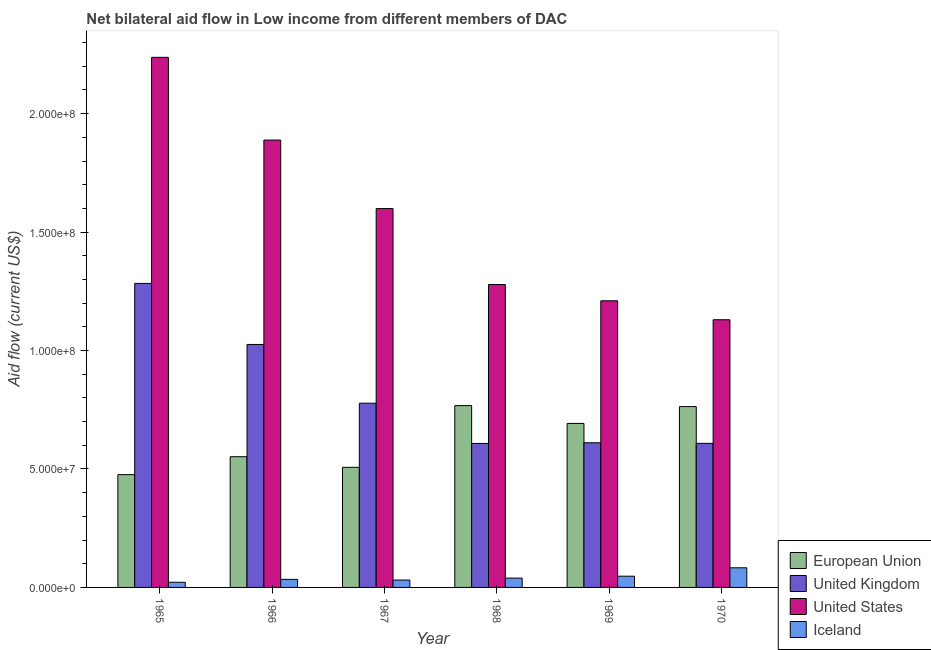How many different coloured bars are there?
Provide a succinct answer. 4. Are the number of bars on each tick of the X-axis equal?
Keep it short and to the point. Yes. How many bars are there on the 4th tick from the left?
Provide a short and direct response. 4. How many bars are there on the 6th tick from the right?
Ensure brevity in your answer.  4. What is the label of the 3rd group of bars from the left?
Your answer should be very brief. 1967. What is the amount of aid given by us in 1968?
Offer a very short reply. 1.28e+08. Across all years, what is the maximum amount of aid given by eu?
Provide a succinct answer. 7.68e+07. Across all years, what is the minimum amount of aid given by us?
Your response must be concise. 1.13e+08. In which year was the amount of aid given by uk maximum?
Your answer should be compact. 1965. In which year was the amount of aid given by us minimum?
Keep it short and to the point. 1970. What is the total amount of aid given by eu in the graph?
Provide a succinct answer. 3.76e+08. What is the difference between the amount of aid given by eu in 1968 and that in 1970?
Provide a short and direct response. 4.10e+05. What is the difference between the amount of aid given by iceland in 1967 and the amount of aid given by uk in 1966?
Ensure brevity in your answer.  -2.80e+05. What is the average amount of aid given by uk per year?
Your response must be concise. 8.19e+07. What is the ratio of the amount of aid given by eu in 1966 to that in 1968?
Your answer should be compact. 0.72. What is the difference between the highest and the second highest amount of aid given by us?
Ensure brevity in your answer.  3.49e+07. What is the difference between the highest and the lowest amount of aid given by uk?
Ensure brevity in your answer.  6.76e+07. In how many years, is the amount of aid given by uk greater than the average amount of aid given by uk taken over all years?
Provide a short and direct response. 2. What does the 1st bar from the left in 1965 represents?
Ensure brevity in your answer.  European Union. How many bars are there?
Ensure brevity in your answer.  24. Are all the bars in the graph horizontal?
Keep it short and to the point. No. How many years are there in the graph?
Offer a very short reply. 6. What is the difference between two consecutive major ticks on the Y-axis?
Provide a short and direct response. 5.00e+07. What is the title of the graph?
Provide a succinct answer. Net bilateral aid flow in Low income from different members of DAC. What is the Aid flow (current US$) of European Union in 1965?
Your answer should be compact. 4.76e+07. What is the Aid flow (current US$) in United Kingdom in 1965?
Give a very brief answer. 1.28e+08. What is the Aid flow (current US$) of United States in 1965?
Ensure brevity in your answer.  2.24e+08. What is the Aid flow (current US$) of Iceland in 1965?
Offer a very short reply. 2.18e+06. What is the Aid flow (current US$) of European Union in 1966?
Give a very brief answer. 5.52e+07. What is the Aid flow (current US$) of United Kingdom in 1966?
Make the answer very short. 1.03e+08. What is the Aid flow (current US$) in United States in 1966?
Your answer should be compact. 1.89e+08. What is the Aid flow (current US$) in Iceland in 1966?
Your answer should be compact. 3.40e+06. What is the Aid flow (current US$) of European Union in 1967?
Your answer should be compact. 5.07e+07. What is the Aid flow (current US$) of United Kingdom in 1967?
Your answer should be compact. 7.78e+07. What is the Aid flow (current US$) in United States in 1967?
Give a very brief answer. 1.60e+08. What is the Aid flow (current US$) in Iceland in 1967?
Your response must be concise. 3.12e+06. What is the Aid flow (current US$) in European Union in 1968?
Keep it short and to the point. 7.68e+07. What is the Aid flow (current US$) in United Kingdom in 1968?
Offer a very short reply. 6.08e+07. What is the Aid flow (current US$) of United States in 1968?
Give a very brief answer. 1.28e+08. What is the Aid flow (current US$) of Iceland in 1968?
Ensure brevity in your answer.  3.94e+06. What is the Aid flow (current US$) of European Union in 1969?
Your answer should be very brief. 6.92e+07. What is the Aid flow (current US$) of United Kingdom in 1969?
Make the answer very short. 6.11e+07. What is the Aid flow (current US$) in United States in 1969?
Give a very brief answer. 1.21e+08. What is the Aid flow (current US$) in Iceland in 1969?
Provide a succinct answer. 4.74e+06. What is the Aid flow (current US$) of European Union in 1970?
Offer a terse response. 7.63e+07. What is the Aid flow (current US$) of United Kingdom in 1970?
Make the answer very short. 6.08e+07. What is the Aid flow (current US$) in United States in 1970?
Ensure brevity in your answer.  1.13e+08. What is the Aid flow (current US$) in Iceland in 1970?
Provide a succinct answer. 8.29e+06. Across all years, what is the maximum Aid flow (current US$) of European Union?
Your answer should be compact. 7.68e+07. Across all years, what is the maximum Aid flow (current US$) in United Kingdom?
Your response must be concise. 1.28e+08. Across all years, what is the maximum Aid flow (current US$) of United States?
Your answer should be very brief. 2.24e+08. Across all years, what is the maximum Aid flow (current US$) in Iceland?
Make the answer very short. 8.29e+06. Across all years, what is the minimum Aid flow (current US$) of European Union?
Your response must be concise. 4.76e+07. Across all years, what is the minimum Aid flow (current US$) in United Kingdom?
Provide a short and direct response. 6.08e+07. Across all years, what is the minimum Aid flow (current US$) of United States?
Ensure brevity in your answer.  1.13e+08. Across all years, what is the minimum Aid flow (current US$) of Iceland?
Keep it short and to the point. 2.18e+06. What is the total Aid flow (current US$) of European Union in the graph?
Make the answer very short. 3.76e+08. What is the total Aid flow (current US$) in United Kingdom in the graph?
Your response must be concise. 4.91e+08. What is the total Aid flow (current US$) of United States in the graph?
Offer a very short reply. 9.34e+08. What is the total Aid flow (current US$) of Iceland in the graph?
Your answer should be very brief. 2.57e+07. What is the difference between the Aid flow (current US$) in European Union in 1965 and that in 1966?
Your response must be concise. -7.57e+06. What is the difference between the Aid flow (current US$) in United Kingdom in 1965 and that in 1966?
Ensure brevity in your answer.  2.58e+07. What is the difference between the Aid flow (current US$) in United States in 1965 and that in 1966?
Provide a short and direct response. 3.49e+07. What is the difference between the Aid flow (current US$) of Iceland in 1965 and that in 1966?
Keep it short and to the point. -1.22e+06. What is the difference between the Aid flow (current US$) of European Union in 1965 and that in 1967?
Offer a terse response. -3.09e+06. What is the difference between the Aid flow (current US$) of United Kingdom in 1965 and that in 1967?
Ensure brevity in your answer.  5.06e+07. What is the difference between the Aid flow (current US$) of United States in 1965 and that in 1967?
Your response must be concise. 6.38e+07. What is the difference between the Aid flow (current US$) in Iceland in 1965 and that in 1967?
Ensure brevity in your answer.  -9.40e+05. What is the difference between the Aid flow (current US$) in European Union in 1965 and that in 1968?
Provide a succinct answer. -2.91e+07. What is the difference between the Aid flow (current US$) of United Kingdom in 1965 and that in 1968?
Give a very brief answer. 6.76e+07. What is the difference between the Aid flow (current US$) of United States in 1965 and that in 1968?
Offer a very short reply. 9.59e+07. What is the difference between the Aid flow (current US$) of Iceland in 1965 and that in 1968?
Your answer should be very brief. -1.76e+06. What is the difference between the Aid flow (current US$) of European Union in 1965 and that in 1969?
Offer a terse response. -2.16e+07. What is the difference between the Aid flow (current US$) in United Kingdom in 1965 and that in 1969?
Your response must be concise. 6.73e+07. What is the difference between the Aid flow (current US$) of United States in 1965 and that in 1969?
Offer a very short reply. 1.03e+08. What is the difference between the Aid flow (current US$) of Iceland in 1965 and that in 1969?
Provide a short and direct response. -2.56e+06. What is the difference between the Aid flow (current US$) in European Union in 1965 and that in 1970?
Provide a succinct answer. -2.87e+07. What is the difference between the Aid flow (current US$) in United Kingdom in 1965 and that in 1970?
Your response must be concise. 6.75e+07. What is the difference between the Aid flow (current US$) in United States in 1965 and that in 1970?
Ensure brevity in your answer.  1.11e+08. What is the difference between the Aid flow (current US$) in Iceland in 1965 and that in 1970?
Offer a terse response. -6.11e+06. What is the difference between the Aid flow (current US$) in European Union in 1966 and that in 1967?
Offer a very short reply. 4.48e+06. What is the difference between the Aid flow (current US$) in United Kingdom in 1966 and that in 1967?
Your response must be concise. 2.48e+07. What is the difference between the Aid flow (current US$) of United States in 1966 and that in 1967?
Ensure brevity in your answer.  2.89e+07. What is the difference between the Aid flow (current US$) of European Union in 1966 and that in 1968?
Keep it short and to the point. -2.16e+07. What is the difference between the Aid flow (current US$) in United Kingdom in 1966 and that in 1968?
Ensure brevity in your answer.  4.18e+07. What is the difference between the Aid flow (current US$) of United States in 1966 and that in 1968?
Provide a short and direct response. 6.10e+07. What is the difference between the Aid flow (current US$) of Iceland in 1966 and that in 1968?
Ensure brevity in your answer.  -5.40e+05. What is the difference between the Aid flow (current US$) of European Union in 1966 and that in 1969?
Your answer should be very brief. -1.40e+07. What is the difference between the Aid flow (current US$) of United Kingdom in 1966 and that in 1969?
Your answer should be very brief. 4.15e+07. What is the difference between the Aid flow (current US$) of United States in 1966 and that in 1969?
Provide a succinct answer. 6.78e+07. What is the difference between the Aid flow (current US$) in Iceland in 1966 and that in 1969?
Your response must be concise. -1.34e+06. What is the difference between the Aid flow (current US$) in European Union in 1966 and that in 1970?
Your answer should be compact. -2.12e+07. What is the difference between the Aid flow (current US$) of United Kingdom in 1966 and that in 1970?
Make the answer very short. 4.18e+07. What is the difference between the Aid flow (current US$) of United States in 1966 and that in 1970?
Your answer should be very brief. 7.58e+07. What is the difference between the Aid flow (current US$) in Iceland in 1966 and that in 1970?
Offer a very short reply. -4.89e+06. What is the difference between the Aid flow (current US$) in European Union in 1967 and that in 1968?
Ensure brevity in your answer.  -2.60e+07. What is the difference between the Aid flow (current US$) of United Kingdom in 1967 and that in 1968?
Provide a succinct answer. 1.70e+07. What is the difference between the Aid flow (current US$) of United States in 1967 and that in 1968?
Provide a succinct answer. 3.21e+07. What is the difference between the Aid flow (current US$) in Iceland in 1967 and that in 1968?
Make the answer very short. -8.20e+05. What is the difference between the Aid flow (current US$) of European Union in 1967 and that in 1969?
Your answer should be very brief. -1.85e+07. What is the difference between the Aid flow (current US$) of United Kingdom in 1967 and that in 1969?
Your response must be concise. 1.67e+07. What is the difference between the Aid flow (current US$) in United States in 1967 and that in 1969?
Make the answer very short. 3.89e+07. What is the difference between the Aid flow (current US$) in Iceland in 1967 and that in 1969?
Offer a terse response. -1.62e+06. What is the difference between the Aid flow (current US$) of European Union in 1967 and that in 1970?
Your response must be concise. -2.56e+07. What is the difference between the Aid flow (current US$) in United Kingdom in 1967 and that in 1970?
Your response must be concise. 1.70e+07. What is the difference between the Aid flow (current US$) of United States in 1967 and that in 1970?
Your response must be concise. 4.69e+07. What is the difference between the Aid flow (current US$) in Iceland in 1967 and that in 1970?
Keep it short and to the point. -5.17e+06. What is the difference between the Aid flow (current US$) in European Union in 1968 and that in 1969?
Keep it short and to the point. 7.52e+06. What is the difference between the Aid flow (current US$) of United States in 1968 and that in 1969?
Give a very brief answer. 6.85e+06. What is the difference between the Aid flow (current US$) of Iceland in 1968 and that in 1969?
Your response must be concise. -8.00e+05. What is the difference between the Aid flow (current US$) of United States in 1968 and that in 1970?
Your answer should be compact. 1.48e+07. What is the difference between the Aid flow (current US$) of Iceland in 1968 and that in 1970?
Your response must be concise. -4.35e+06. What is the difference between the Aid flow (current US$) of European Union in 1969 and that in 1970?
Offer a terse response. -7.11e+06. What is the difference between the Aid flow (current US$) in United Kingdom in 1969 and that in 1970?
Your response must be concise. 2.60e+05. What is the difference between the Aid flow (current US$) of United States in 1969 and that in 1970?
Make the answer very short. 8.00e+06. What is the difference between the Aid flow (current US$) of Iceland in 1969 and that in 1970?
Your response must be concise. -3.55e+06. What is the difference between the Aid flow (current US$) of European Union in 1965 and the Aid flow (current US$) of United Kingdom in 1966?
Offer a terse response. -5.50e+07. What is the difference between the Aid flow (current US$) in European Union in 1965 and the Aid flow (current US$) in United States in 1966?
Offer a very short reply. -1.41e+08. What is the difference between the Aid flow (current US$) in European Union in 1965 and the Aid flow (current US$) in Iceland in 1966?
Make the answer very short. 4.42e+07. What is the difference between the Aid flow (current US$) in United Kingdom in 1965 and the Aid flow (current US$) in United States in 1966?
Offer a very short reply. -6.05e+07. What is the difference between the Aid flow (current US$) in United Kingdom in 1965 and the Aid flow (current US$) in Iceland in 1966?
Keep it short and to the point. 1.25e+08. What is the difference between the Aid flow (current US$) of United States in 1965 and the Aid flow (current US$) of Iceland in 1966?
Provide a short and direct response. 2.20e+08. What is the difference between the Aid flow (current US$) of European Union in 1965 and the Aid flow (current US$) of United Kingdom in 1967?
Offer a terse response. -3.02e+07. What is the difference between the Aid flow (current US$) in European Union in 1965 and the Aid flow (current US$) in United States in 1967?
Provide a short and direct response. -1.12e+08. What is the difference between the Aid flow (current US$) in European Union in 1965 and the Aid flow (current US$) in Iceland in 1967?
Give a very brief answer. 4.45e+07. What is the difference between the Aid flow (current US$) in United Kingdom in 1965 and the Aid flow (current US$) in United States in 1967?
Keep it short and to the point. -3.16e+07. What is the difference between the Aid flow (current US$) in United Kingdom in 1965 and the Aid flow (current US$) in Iceland in 1967?
Offer a very short reply. 1.25e+08. What is the difference between the Aid flow (current US$) in United States in 1965 and the Aid flow (current US$) in Iceland in 1967?
Keep it short and to the point. 2.21e+08. What is the difference between the Aid flow (current US$) of European Union in 1965 and the Aid flow (current US$) of United Kingdom in 1968?
Your response must be concise. -1.32e+07. What is the difference between the Aid flow (current US$) in European Union in 1965 and the Aid flow (current US$) in United States in 1968?
Provide a short and direct response. -8.02e+07. What is the difference between the Aid flow (current US$) of European Union in 1965 and the Aid flow (current US$) of Iceland in 1968?
Offer a terse response. 4.37e+07. What is the difference between the Aid flow (current US$) of United Kingdom in 1965 and the Aid flow (current US$) of United States in 1968?
Provide a succinct answer. 4.80e+05. What is the difference between the Aid flow (current US$) of United Kingdom in 1965 and the Aid flow (current US$) of Iceland in 1968?
Offer a terse response. 1.24e+08. What is the difference between the Aid flow (current US$) in United States in 1965 and the Aid flow (current US$) in Iceland in 1968?
Offer a very short reply. 2.20e+08. What is the difference between the Aid flow (current US$) of European Union in 1965 and the Aid flow (current US$) of United Kingdom in 1969?
Your response must be concise. -1.35e+07. What is the difference between the Aid flow (current US$) in European Union in 1965 and the Aid flow (current US$) in United States in 1969?
Offer a very short reply. -7.34e+07. What is the difference between the Aid flow (current US$) of European Union in 1965 and the Aid flow (current US$) of Iceland in 1969?
Keep it short and to the point. 4.29e+07. What is the difference between the Aid flow (current US$) of United Kingdom in 1965 and the Aid flow (current US$) of United States in 1969?
Your answer should be very brief. 7.33e+06. What is the difference between the Aid flow (current US$) of United Kingdom in 1965 and the Aid flow (current US$) of Iceland in 1969?
Give a very brief answer. 1.24e+08. What is the difference between the Aid flow (current US$) in United States in 1965 and the Aid flow (current US$) in Iceland in 1969?
Provide a succinct answer. 2.19e+08. What is the difference between the Aid flow (current US$) in European Union in 1965 and the Aid flow (current US$) in United Kingdom in 1970?
Keep it short and to the point. -1.32e+07. What is the difference between the Aid flow (current US$) in European Union in 1965 and the Aid flow (current US$) in United States in 1970?
Give a very brief answer. -6.54e+07. What is the difference between the Aid flow (current US$) of European Union in 1965 and the Aid flow (current US$) of Iceland in 1970?
Ensure brevity in your answer.  3.93e+07. What is the difference between the Aid flow (current US$) of United Kingdom in 1965 and the Aid flow (current US$) of United States in 1970?
Provide a succinct answer. 1.53e+07. What is the difference between the Aid flow (current US$) in United Kingdom in 1965 and the Aid flow (current US$) in Iceland in 1970?
Your answer should be compact. 1.20e+08. What is the difference between the Aid flow (current US$) in United States in 1965 and the Aid flow (current US$) in Iceland in 1970?
Your answer should be very brief. 2.15e+08. What is the difference between the Aid flow (current US$) in European Union in 1966 and the Aid flow (current US$) in United Kingdom in 1967?
Provide a short and direct response. -2.26e+07. What is the difference between the Aid flow (current US$) in European Union in 1966 and the Aid flow (current US$) in United States in 1967?
Your response must be concise. -1.05e+08. What is the difference between the Aid flow (current US$) in European Union in 1966 and the Aid flow (current US$) in Iceland in 1967?
Keep it short and to the point. 5.21e+07. What is the difference between the Aid flow (current US$) in United Kingdom in 1966 and the Aid flow (current US$) in United States in 1967?
Provide a succinct answer. -5.74e+07. What is the difference between the Aid flow (current US$) of United Kingdom in 1966 and the Aid flow (current US$) of Iceland in 1967?
Your answer should be compact. 9.94e+07. What is the difference between the Aid flow (current US$) in United States in 1966 and the Aid flow (current US$) in Iceland in 1967?
Provide a succinct answer. 1.86e+08. What is the difference between the Aid flow (current US$) in European Union in 1966 and the Aid flow (current US$) in United Kingdom in 1968?
Your answer should be very brief. -5.60e+06. What is the difference between the Aid flow (current US$) of European Union in 1966 and the Aid flow (current US$) of United States in 1968?
Your answer should be compact. -7.27e+07. What is the difference between the Aid flow (current US$) in European Union in 1966 and the Aid flow (current US$) in Iceland in 1968?
Your answer should be very brief. 5.12e+07. What is the difference between the Aid flow (current US$) of United Kingdom in 1966 and the Aid flow (current US$) of United States in 1968?
Your answer should be very brief. -2.53e+07. What is the difference between the Aid flow (current US$) of United Kingdom in 1966 and the Aid flow (current US$) of Iceland in 1968?
Give a very brief answer. 9.86e+07. What is the difference between the Aid flow (current US$) in United States in 1966 and the Aid flow (current US$) in Iceland in 1968?
Keep it short and to the point. 1.85e+08. What is the difference between the Aid flow (current US$) of European Union in 1966 and the Aid flow (current US$) of United Kingdom in 1969?
Provide a short and direct response. -5.89e+06. What is the difference between the Aid flow (current US$) in European Union in 1966 and the Aid flow (current US$) in United States in 1969?
Keep it short and to the point. -6.58e+07. What is the difference between the Aid flow (current US$) in European Union in 1966 and the Aid flow (current US$) in Iceland in 1969?
Ensure brevity in your answer.  5.04e+07. What is the difference between the Aid flow (current US$) of United Kingdom in 1966 and the Aid flow (current US$) of United States in 1969?
Keep it short and to the point. -1.84e+07. What is the difference between the Aid flow (current US$) in United Kingdom in 1966 and the Aid flow (current US$) in Iceland in 1969?
Offer a terse response. 9.78e+07. What is the difference between the Aid flow (current US$) of United States in 1966 and the Aid flow (current US$) of Iceland in 1969?
Keep it short and to the point. 1.84e+08. What is the difference between the Aid flow (current US$) of European Union in 1966 and the Aid flow (current US$) of United Kingdom in 1970?
Your response must be concise. -5.63e+06. What is the difference between the Aid flow (current US$) of European Union in 1966 and the Aid flow (current US$) of United States in 1970?
Your answer should be very brief. -5.78e+07. What is the difference between the Aid flow (current US$) in European Union in 1966 and the Aid flow (current US$) in Iceland in 1970?
Offer a very short reply. 4.69e+07. What is the difference between the Aid flow (current US$) of United Kingdom in 1966 and the Aid flow (current US$) of United States in 1970?
Offer a terse response. -1.04e+07. What is the difference between the Aid flow (current US$) in United Kingdom in 1966 and the Aid flow (current US$) in Iceland in 1970?
Offer a terse response. 9.43e+07. What is the difference between the Aid flow (current US$) of United States in 1966 and the Aid flow (current US$) of Iceland in 1970?
Offer a terse response. 1.81e+08. What is the difference between the Aid flow (current US$) in European Union in 1967 and the Aid flow (current US$) in United Kingdom in 1968?
Your answer should be compact. -1.01e+07. What is the difference between the Aid flow (current US$) in European Union in 1967 and the Aid flow (current US$) in United States in 1968?
Provide a short and direct response. -7.72e+07. What is the difference between the Aid flow (current US$) in European Union in 1967 and the Aid flow (current US$) in Iceland in 1968?
Offer a very short reply. 4.68e+07. What is the difference between the Aid flow (current US$) of United Kingdom in 1967 and the Aid flow (current US$) of United States in 1968?
Provide a short and direct response. -5.01e+07. What is the difference between the Aid flow (current US$) in United Kingdom in 1967 and the Aid flow (current US$) in Iceland in 1968?
Offer a very short reply. 7.38e+07. What is the difference between the Aid flow (current US$) in United States in 1967 and the Aid flow (current US$) in Iceland in 1968?
Provide a succinct answer. 1.56e+08. What is the difference between the Aid flow (current US$) of European Union in 1967 and the Aid flow (current US$) of United Kingdom in 1969?
Give a very brief answer. -1.04e+07. What is the difference between the Aid flow (current US$) of European Union in 1967 and the Aid flow (current US$) of United States in 1969?
Give a very brief answer. -7.03e+07. What is the difference between the Aid flow (current US$) of European Union in 1967 and the Aid flow (current US$) of Iceland in 1969?
Your response must be concise. 4.60e+07. What is the difference between the Aid flow (current US$) of United Kingdom in 1967 and the Aid flow (current US$) of United States in 1969?
Provide a succinct answer. -4.32e+07. What is the difference between the Aid flow (current US$) of United Kingdom in 1967 and the Aid flow (current US$) of Iceland in 1969?
Keep it short and to the point. 7.30e+07. What is the difference between the Aid flow (current US$) in United States in 1967 and the Aid flow (current US$) in Iceland in 1969?
Offer a very short reply. 1.55e+08. What is the difference between the Aid flow (current US$) in European Union in 1967 and the Aid flow (current US$) in United Kingdom in 1970?
Offer a terse response. -1.01e+07. What is the difference between the Aid flow (current US$) in European Union in 1967 and the Aid flow (current US$) in United States in 1970?
Make the answer very short. -6.23e+07. What is the difference between the Aid flow (current US$) in European Union in 1967 and the Aid flow (current US$) in Iceland in 1970?
Give a very brief answer. 4.24e+07. What is the difference between the Aid flow (current US$) of United Kingdom in 1967 and the Aid flow (current US$) of United States in 1970?
Your answer should be compact. -3.52e+07. What is the difference between the Aid flow (current US$) of United Kingdom in 1967 and the Aid flow (current US$) of Iceland in 1970?
Keep it short and to the point. 6.95e+07. What is the difference between the Aid flow (current US$) of United States in 1967 and the Aid flow (current US$) of Iceland in 1970?
Your answer should be very brief. 1.52e+08. What is the difference between the Aid flow (current US$) of European Union in 1968 and the Aid flow (current US$) of United Kingdom in 1969?
Your answer should be compact. 1.57e+07. What is the difference between the Aid flow (current US$) of European Union in 1968 and the Aid flow (current US$) of United States in 1969?
Provide a short and direct response. -4.42e+07. What is the difference between the Aid flow (current US$) of European Union in 1968 and the Aid flow (current US$) of Iceland in 1969?
Your response must be concise. 7.20e+07. What is the difference between the Aid flow (current US$) of United Kingdom in 1968 and the Aid flow (current US$) of United States in 1969?
Give a very brief answer. -6.02e+07. What is the difference between the Aid flow (current US$) in United Kingdom in 1968 and the Aid flow (current US$) in Iceland in 1969?
Provide a succinct answer. 5.60e+07. What is the difference between the Aid flow (current US$) in United States in 1968 and the Aid flow (current US$) in Iceland in 1969?
Offer a terse response. 1.23e+08. What is the difference between the Aid flow (current US$) of European Union in 1968 and the Aid flow (current US$) of United Kingdom in 1970?
Your response must be concise. 1.59e+07. What is the difference between the Aid flow (current US$) of European Union in 1968 and the Aid flow (current US$) of United States in 1970?
Make the answer very short. -3.62e+07. What is the difference between the Aid flow (current US$) of European Union in 1968 and the Aid flow (current US$) of Iceland in 1970?
Your answer should be very brief. 6.85e+07. What is the difference between the Aid flow (current US$) of United Kingdom in 1968 and the Aid flow (current US$) of United States in 1970?
Make the answer very short. -5.22e+07. What is the difference between the Aid flow (current US$) of United Kingdom in 1968 and the Aid flow (current US$) of Iceland in 1970?
Offer a terse response. 5.25e+07. What is the difference between the Aid flow (current US$) of United States in 1968 and the Aid flow (current US$) of Iceland in 1970?
Offer a very short reply. 1.20e+08. What is the difference between the Aid flow (current US$) in European Union in 1969 and the Aid flow (current US$) in United Kingdom in 1970?
Keep it short and to the point. 8.42e+06. What is the difference between the Aid flow (current US$) of European Union in 1969 and the Aid flow (current US$) of United States in 1970?
Ensure brevity in your answer.  -4.38e+07. What is the difference between the Aid flow (current US$) in European Union in 1969 and the Aid flow (current US$) in Iceland in 1970?
Provide a succinct answer. 6.09e+07. What is the difference between the Aid flow (current US$) of United Kingdom in 1969 and the Aid flow (current US$) of United States in 1970?
Your answer should be very brief. -5.19e+07. What is the difference between the Aid flow (current US$) in United Kingdom in 1969 and the Aid flow (current US$) in Iceland in 1970?
Keep it short and to the point. 5.28e+07. What is the difference between the Aid flow (current US$) of United States in 1969 and the Aid flow (current US$) of Iceland in 1970?
Offer a terse response. 1.13e+08. What is the average Aid flow (current US$) of European Union per year?
Provide a succinct answer. 6.26e+07. What is the average Aid flow (current US$) in United Kingdom per year?
Provide a succinct answer. 8.19e+07. What is the average Aid flow (current US$) of United States per year?
Give a very brief answer. 1.56e+08. What is the average Aid flow (current US$) of Iceland per year?
Your answer should be very brief. 4.28e+06. In the year 1965, what is the difference between the Aid flow (current US$) of European Union and Aid flow (current US$) of United Kingdom?
Make the answer very short. -8.07e+07. In the year 1965, what is the difference between the Aid flow (current US$) of European Union and Aid flow (current US$) of United States?
Keep it short and to the point. -1.76e+08. In the year 1965, what is the difference between the Aid flow (current US$) in European Union and Aid flow (current US$) in Iceland?
Ensure brevity in your answer.  4.54e+07. In the year 1965, what is the difference between the Aid flow (current US$) of United Kingdom and Aid flow (current US$) of United States?
Offer a terse response. -9.54e+07. In the year 1965, what is the difference between the Aid flow (current US$) of United Kingdom and Aid flow (current US$) of Iceland?
Make the answer very short. 1.26e+08. In the year 1965, what is the difference between the Aid flow (current US$) in United States and Aid flow (current US$) in Iceland?
Your answer should be compact. 2.22e+08. In the year 1966, what is the difference between the Aid flow (current US$) in European Union and Aid flow (current US$) in United Kingdom?
Offer a very short reply. -4.74e+07. In the year 1966, what is the difference between the Aid flow (current US$) in European Union and Aid flow (current US$) in United States?
Provide a succinct answer. -1.34e+08. In the year 1966, what is the difference between the Aid flow (current US$) in European Union and Aid flow (current US$) in Iceland?
Ensure brevity in your answer.  5.18e+07. In the year 1966, what is the difference between the Aid flow (current US$) in United Kingdom and Aid flow (current US$) in United States?
Your answer should be very brief. -8.63e+07. In the year 1966, what is the difference between the Aid flow (current US$) in United Kingdom and Aid flow (current US$) in Iceland?
Make the answer very short. 9.92e+07. In the year 1966, what is the difference between the Aid flow (current US$) of United States and Aid flow (current US$) of Iceland?
Provide a short and direct response. 1.85e+08. In the year 1967, what is the difference between the Aid flow (current US$) of European Union and Aid flow (current US$) of United Kingdom?
Keep it short and to the point. -2.71e+07. In the year 1967, what is the difference between the Aid flow (current US$) in European Union and Aid flow (current US$) in United States?
Your answer should be compact. -1.09e+08. In the year 1967, what is the difference between the Aid flow (current US$) in European Union and Aid flow (current US$) in Iceland?
Offer a terse response. 4.76e+07. In the year 1967, what is the difference between the Aid flow (current US$) in United Kingdom and Aid flow (current US$) in United States?
Make the answer very short. -8.22e+07. In the year 1967, what is the difference between the Aid flow (current US$) of United Kingdom and Aid flow (current US$) of Iceland?
Keep it short and to the point. 7.46e+07. In the year 1967, what is the difference between the Aid flow (current US$) in United States and Aid flow (current US$) in Iceland?
Provide a short and direct response. 1.57e+08. In the year 1968, what is the difference between the Aid flow (current US$) of European Union and Aid flow (current US$) of United Kingdom?
Keep it short and to the point. 1.60e+07. In the year 1968, what is the difference between the Aid flow (current US$) in European Union and Aid flow (current US$) in United States?
Your answer should be compact. -5.11e+07. In the year 1968, what is the difference between the Aid flow (current US$) of European Union and Aid flow (current US$) of Iceland?
Offer a terse response. 7.28e+07. In the year 1968, what is the difference between the Aid flow (current US$) of United Kingdom and Aid flow (current US$) of United States?
Make the answer very short. -6.71e+07. In the year 1968, what is the difference between the Aid flow (current US$) of United Kingdom and Aid flow (current US$) of Iceland?
Your answer should be very brief. 5.68e+07. In the year 1968, what is the difference between the Aid flow (current US$) in United States and Aid flow (current US$) in Iceland?
Your response must be concise. 1.24e+08. In the year 1969, what is the difference between the Aid flow (current US$) of European Union and Aid flow (current US$) of United Kingdom?
Make the answer very short. 8.16e+06. In the year 1969, what is the difference between the Aid flow (current US$) of European Union and Aid flow (current US$) of United States?
Give a very brief answer. -5.18e+07. In the year 1969, what is the difference between the Aid flow (current US$) of European Union and Aid flow (current US$) of Iceland?
Keep it short and to the point. 6.45e+07. In the year 1969, what is the difference between the Aid flow (current US$) in United Kingdom and Aid flow (current US$) in United States?
Your answer should be compact. -5.99e+07. In the year 1969, what is the difference between the Aid flow (current US$) of United Kingdom and Aid flow (current US$) of Iceland?
Provide a short and direct response. 5.63e+07. In the year 1969, what is the difference between the Aid flow (current US$) of United States and Aid flow (current US$) of Iceland?
Keep it short and to the point. 1.16e+08. In the year 1970, what is the difference between the Aid flow (current US$) in European Union and Aid flow (current US$) in United Kingdom?
Provide a succinct answer. 1.55e+07. In the year 1970, what is the difference between the Aid flow (current US$) of European Union and Aid flow (current US$) of United States?
Your response must be concise. -3.67e+07. In the year 1970, what is the difference between the Aid flow (current US$) of European Union and Aid flow (current US$) of Iceland?
Your answer should be compact. 6.80e+07. In the year 1970, what is the difference between the Aid flow (current US$) in United Kingdom and Aid flow (current US$) in United States?
Provide a short and direct response. -5.22e+07. In the year 1970, what is the difference between the Aid flow (current US$) in United Kingdom and Aid flow (current US$) in Iceland?
Keep it short and to the point. 5.25e+07. In the year 1970, what is the difference between the Aid flow (current US$) of United States and Aid flow (current US$) of Iceland?
Your response must be concise. 1.05e+08. What is the ratio of the Aid flow (current US$) in European Union in 1965 to that in 1966?
Ensure brevity in your answer.  0.86. What is the ratio of the Aid flow (current US$) of United Kingdom in 1965 to that in 1966?
Your answer should be compact. 1.25. What is the ratio of the Aid flow (current US$) of United States in 1965 to that in 1966?
Make the answer very short. 1.18. What is the ratio of the Aid flow (current US$) of Iceland in 1965 to that in 1966?
Make the answer very short. 0.64. What is the ratio of the Aid flow (current US$) in European Union in 1965 to that in 1967?
Ensure brevity in your answer.  0.94. What is the ratio of the Aid flow (current US$) of United Kingdom in 1965 to that in 1967?
Provide a short and direct response. 1.65. What is the ratio of the Aid flow (current US$) of United States in 1965 to that in 1967?
Provide a succinct answer. 1.4. What is the ratio of the Aid flow (current US$) of Iceland in 1965 to that in 1967?
Your answer should be compact. 0.7. What is the ratio of the Aid flow (current US$) of European Union in 1965 to that in 1968?
Ensure brevity in your answer.  0.62. What is the ratio of the Aid flow (current US$) in United Kingdom in 1965 to that in 1968?
Your response must be concise. 2.11. What is the ratio of the Aid flow (current US$) in United States in 1965 to that in 1968?
Offer a terse response. 1.75. What is the ratio of the Aid flow (current US$) in Iceland in 1965 to that in 1968?
Keep it short and to the point. 0.55. What is the ratio of the Aid flow (current US$) of European Union in 1965 to that in 1969?
Offer a terse response. 0.69. What is the ratio of the Aid flow (current US$) of United Kingdom in 1965 to that in 1969?
Offer a terse response. 2.1. What is the ratio of the Aid flow (current US$) of United States in 1965 to that in 1969?
Ensure brevity in your answer.  1.85. What is the ratio of the Aid flow (current US$) of Iceland in 1965 to that in 1969?
Keep it short and to the point. 0.46. What is the ratio of the Aid flow (current US$) in European Union in 1965 to that in 1970?
Give a very brief answer. 0.62. What is the ratio of the Aid flow (current US$) in United Kingdom in 1965 to that in 1970?
Ensure brevity in your answer.  2.11. What is the ratio of the Aid flow (current US$) in United States in 1965 to that in 1970?
Keep it short and to the point. 1.98. What is the ratio of the Aid flow (current US$) in Iceland in 1965 to that in 1970?
Give a very brief answer. 0.26. What is the ratio of the Aid flow (current US$) of European Union in 1966 to that in 1967?
Give a very brief answer. 1.09. What is the ratio of the Aid flow (current US$) in United Kingdom in 1966 to that in 1967?
Your answer should be very brief. 1.32. What is the ratio of the Aid flow (current US$) in United States in 1966 to that in 1967?
Offer a terse response. 1.18. What is the ratio of the Aid flow (current US$) in Iceland in 1966 to that in 1967?
Your answer should be compact. 1.09. What is the ratio of the Aid flow (current US$) in European Union in 1966 to that in 1968?
Provide a succinct answer. 0.72. What is the ratio of the Aid flow (current US$) in United Kingdom in 1966 to that in 1968?
Provide a succinct answer. 1.69. What is the ratio of the Aid flow (current US$) in United States in 1966 to that in 1968?
Keep it short and to the point. 1.48. What is the ratio of the Aid flow (current US$) of Iceland in 1966 to that in 1968?
Keep it short and to the point. 0.86. What is the ratio of the Aid flow (current US$) of European Union in 1966 to that in 1969?
Give a very brief answer. 0.8. What is the ratio of the Aid flow (current US$) of United Kingdom in 1966 to that in 1969?
Give a very brief answer. 1.68. What is the ratio of the Aid flow (current US$) in United States in 1966 to that in 1969?
Your answer should be very brief. 1.56. What is the ratio of the Aid flow (current US$) of Iceland in 1966 to that in 1969?
Your response must be concise. 0.72. What is the ratio of the Aid flow (current US$) in European Union in 1966 to that in 1970?
Your answer should be compact. 0.72. What is the ratio of the Aid flow (current US$) in United Kingdom in 1966 to that in 1970?
Provide a succinct answer. 1.69. What is the ratio of the Aid flow (current US$) in United States in 1966 to that in 1970?
Keep it short and to the point. 1.67. What is the ratio of the Aid flow (current US$) of Iceland in 1966 to that in 1970?
Your answer should be compact. 0.41. What is the ratio of the Aid flow (current US$) of European Union in 1967 to that in 1968?
Your answer should be very brief. 0.66. What is the ratio of the Aid flow (current US$) in United Kingdom in 1967 to that in 1968?
Make the answer very short. 1.28. What is the ratio of the Aid flow (current US$) of United States in 1967 to that in 1968?
Your answer should be very brief. 1.25. What is the ratio of the Aid flow (current US$) in Iceland in 1967 to that in 1968?
Your answer should be compact. 0.79. What is the ratio of the Aid flow (current US$) of European Union in 1967 to that in 1969?
Make the answer very short. 0.73. What is the ratio of the Aid flow (current US$) of United Kingdom in 1967 to that in 1969?
Ensure brevity in your answer.  1.27. What is the ratio of the Aid flow (current US$) in United States in 1967 to that in 1969?
Make the answer very short. 1.32. What is the ratio of the Aid flow (current US$) of Iceland in 1967 to that in 1969?
Make the answer very short. 0.66. What is the ratio of the Aid flow (current US$) in European Union in 1967 to that in 1970?
Provide a succinct answer. 0.66. What is the ratio of the Aid flow (current US$) in United Kingdom in 1967 to that in 1970?
Provide a short and direct response. 1.28. What is the ratio of the Aid flow (current US$) in United States in 1967 to that in 1970?
Your answer should be compact. 1.42. What is the ratio of the Aid flow (current US$) of Iceland in 1967 to that in 1970?
Provide a short and direct response. 0.38. What is the ratio of the Aid flow (current US$) of European Union in 1968 to that in 1969?
Offer a very short reply. 1.11. What is the ratio of the Aid flow (current US$) in United States in 1968 to that in 1969?
Offer a terse response. 1.06. What is the ratio of the Aid flow (current US$) in Iceland in 1968 to that in 1969?
Your response must be concise. 0.83. What is the ratio of the Aid flow (current US$) in European Union in 1968 to that in 1970?
Keep it short and to the point. 1.01. What is the ratio of the Aid flow (current US$) of United Kingdom in 1968 to that in 1970?
Ensure brevity in your answer.  1. What is the ratio of the Aid flow (current US$) of United States in 1968 to that in 1970?
Keep it short and to the point. 1.13. What is the ratio of the Aid flow (current US$) in Iceland in 1968 to that in 1970?
Offer a very short reply. 0.48. What is the ratio of the Aid flow (current US$) of European Union in 1969 to that in 1970?
Provide a short and direct response. 0.91. What is the ratio of the Aid flow (current US$) in United Kingdom in 1969 to that in 1970?
Keep it short and to the point. 1. What is the ratio of the Aid flow (current US$) of United States in 1969 to that in 1970?
Offer a terse response. 1.07. What is the ratio of the Aid flow (current US$) in Iceland in 1969 to that in 1970?
Keep it short and to the point. 0.57. What is the difference between the highest and the second highest Aid flow (current US$) in United Kingdom?
Your answer should be very brief. 2.58e+07. What is the difference between the highest and the second highest Aid flow (current US$) in United States?
Your answer should be very brief. 3.49e+07. What is the difference between the highest and the second highest Aid flow (current US$) of Iceland?
Keep it short and to the point. 3.55e+06. What is the difference between the highest and the lowest Aid flow (current US$) in European Union?
Provide a succinct answer. 2.91e+07. What is the difference between the highest and the lowest Aid flow (current US$) of United Kingdom?
Make the answer very short. 6.76e+07. What is the difference between the highest and the lowest Aid flow (current US$) of United States?
Provide a short and direct response. 1.11e+08. What is the difference between the highest and the lowest Aid flow (current US$) of Iceland?
Keep it short and to the point. 6.11e+06. 